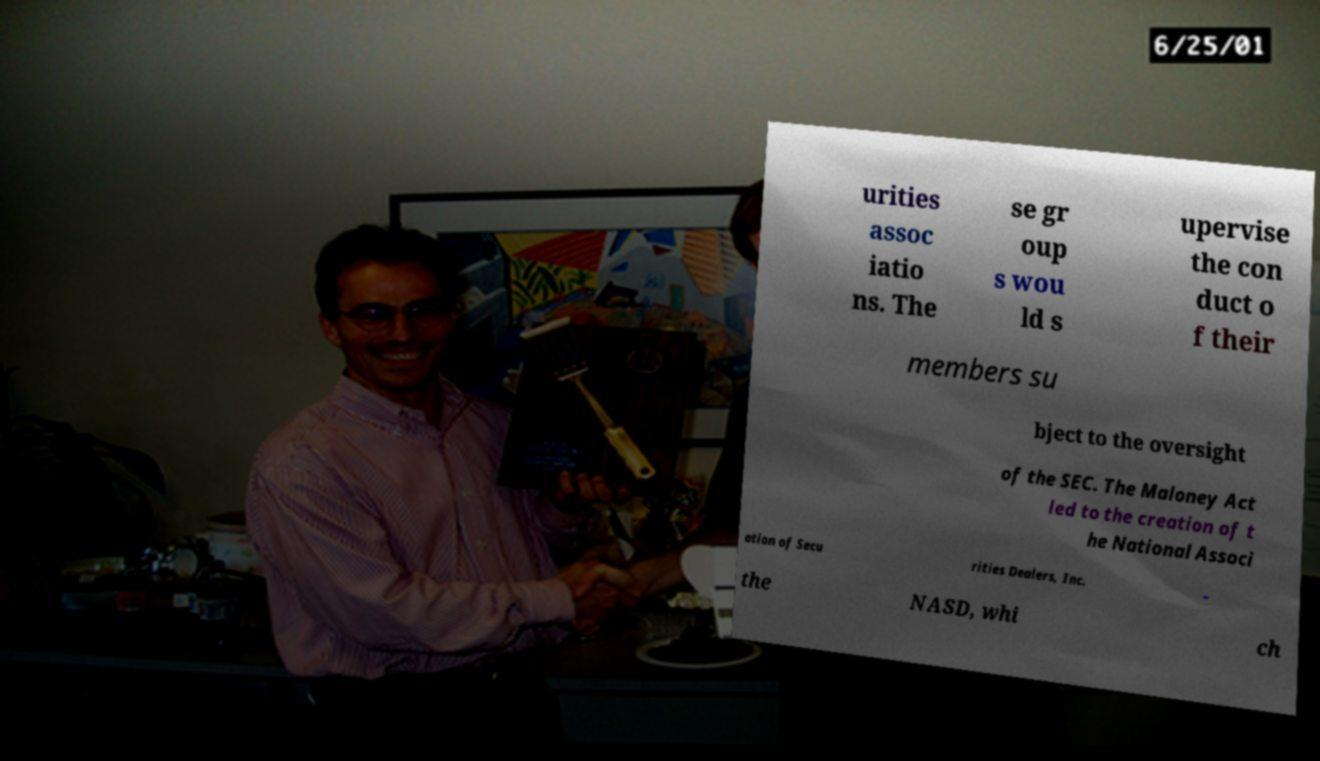Please identify and transcribe the text found in this image. urities assoc iatio ns. The se gr oup s wou ld s upervise the con duct o f their members su bject to the oversight of the SEC. The Maloney Act led to the creation of t he National Associ ation of Secu rities Dealers, Inc. – the NASD, whi ch 